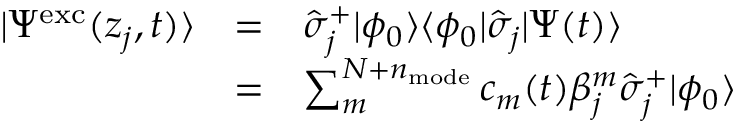Convert formula to latex. <formula><loc_0><loc_0><loc_500><loc_500>\begin{array} { c c l } { | \Psi ^ { e x c } ( z _ { j } , t ) \rangle } & { = } & { \hat { \sigma } _ { j } ^ { + } | \phi _ { 0 } \rangle \langle \phi _ { 0 } | \hat { \sigma } _ { j } | \Psi ( t ) \rangle } \\ & { = } & { \sum _ { m } ^ { N + n _ { m o d e } } c _ { m } ( t ) \beta _ { j } ^ { m } \hat { \sigma } _ { j } ^ { + } | \phi _ { 0 } \rangle } \end{array}</formula> 